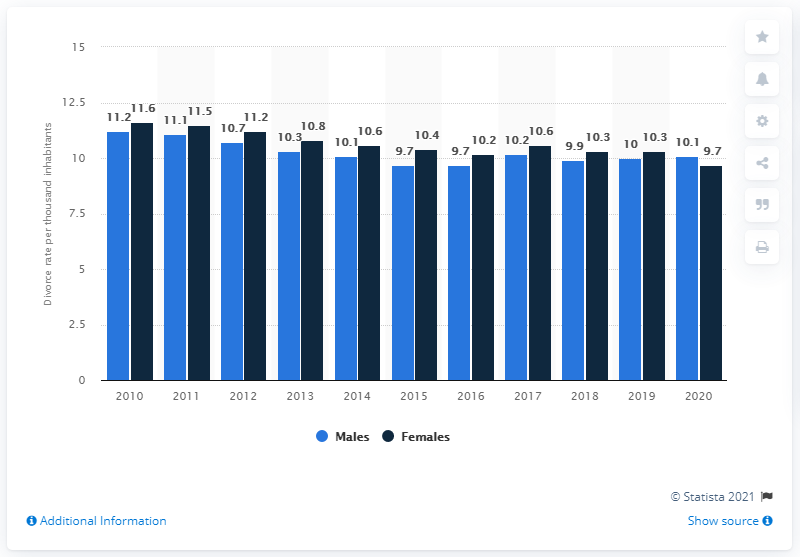Indicate a few pertinent items in this graphic. In 2020, there were 10.1 divorces per 1,000 married and separated males in Norway. 